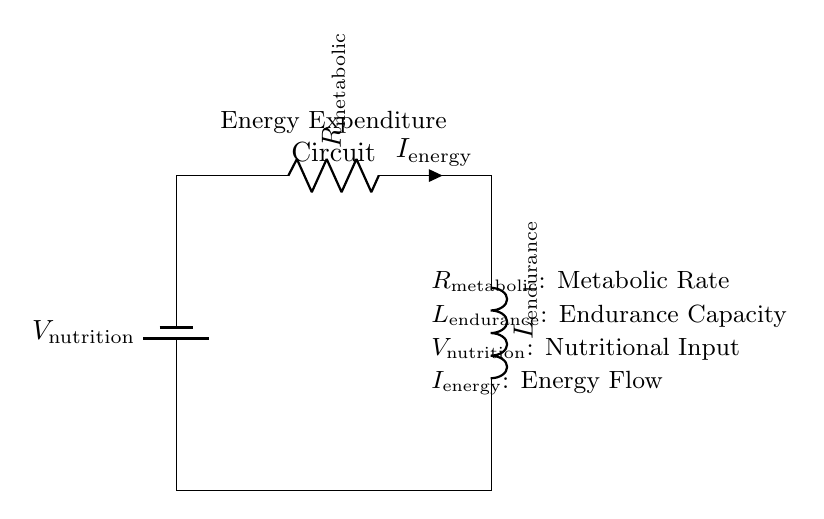What is the voltage of this circuit? The voltage is indicated as V nutrition, which represents the nutritional input in the circuit. It is the potential difference supplied by the battery.
Answer: V nutrition What component represents metabolic rate? The component labeled R metabolic represents the metabolic rate in the circuit, suggesting the resistance encountered as the energy flows through it.
Answer: R metabolic What is the function of the inductor in this circuit? The inductor labeled L endurance indicates the endurance capacity, which relates to how energy is stored and released over time during physical exertion.
Answer: L endurance What does I energy represent in this circuit? I energy represents the energy flow in the circuit, indicating how much energy is being utilized in relation to the metabolic rate and endurance capacity.
Answer: I energy How are the resistor and inductor connected? The resistor and inductor are connected in series, meaning the total current must pass through the resistor before reaching the inductor.
Answer: Series connection 